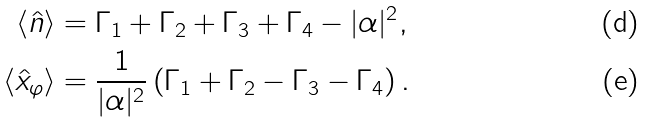Convert formula to latex. <formula><loc_0><loc_0><loc_500><loc_500>\langle \hat { n } \rangle & = \Gamma _ { 1 } + \Gamma _ { 2 } + \Gamma _ { 3 } + \Gamma _ { 4 } - | \alpha | ^ { 2 } , \\ \langle \hat { x } _ { \varphi } \rangle & = \frac { 1 } { | \alpha | ^ { 2 } } \left ( \Gamma _ { 1 } + \Gamma _ { 2 } - \Gamma _ { 3 } - \Gamma _ { 4 } \right ) .</formula> 